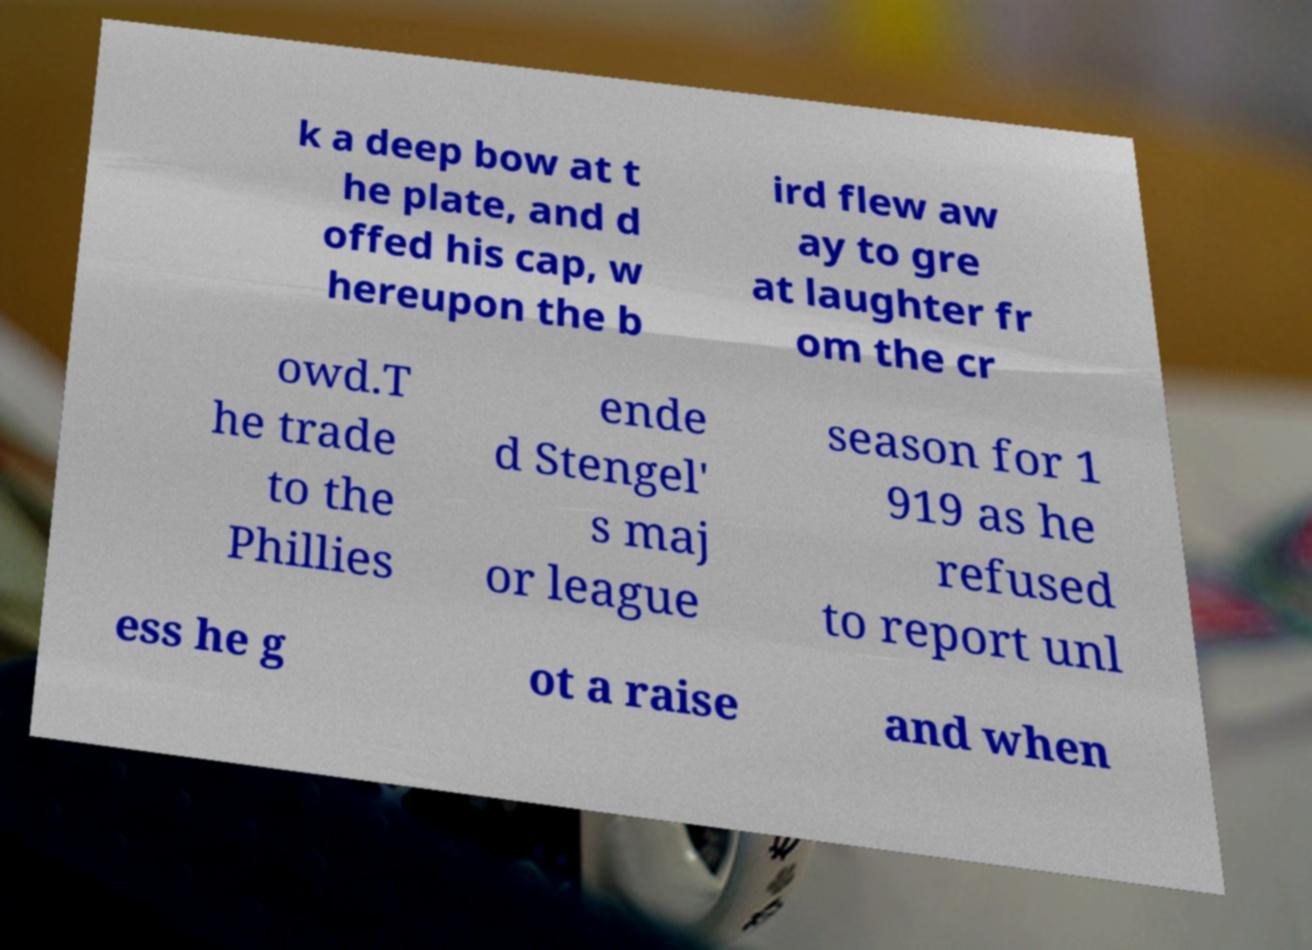There's text embedded in this image that I need extracted. Can you transcribe it verbatim? k a deep bow at t he plate, and d offed his cap, w hereupon the b ird flew aw ay to gre at laughter fr om the cr owd.T he trade to the Phillies ende d Stengel' s maj or league season for 1 919 as he refused to report unl ess he g ot a raise and when 